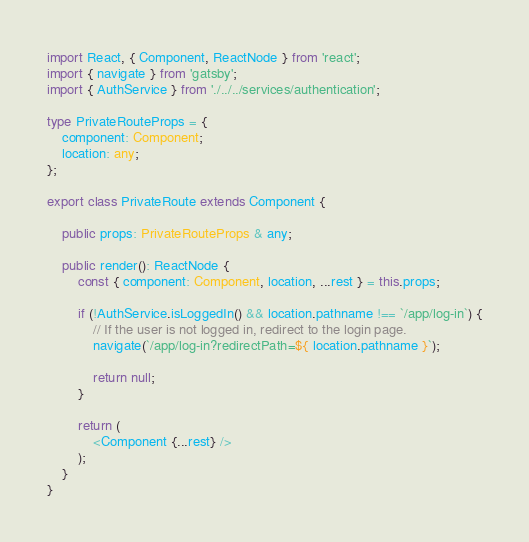Convert code to text. <code><loc_0><loc_0><loc_500><loc_500><_TypeScript_>import React, { Component, ReactNode } from 'react';
import { navigate } from 'gatsby';
import { AuthService } from './../../services/authentication';

type PrivateRouteProps = {
    component: Component;
    location: any;
};

export class PrivateRoute extends Component {

    public props: PrivateRouteProps & any;

    public render(): ReactNode {
        const { component: Component, location, ...rest } = this.props;

        if (!AuthService.isLoggedIn() && location.pathname !== `/app/log-in`) {
            // If the user is not logged in, redirect to the login page.
            navigate(`/app/log-in?redirectPath=${ location.pathname }`);

            return null;
        }

        return (
            <Component {...rest} />
        );
    }
}</code> 